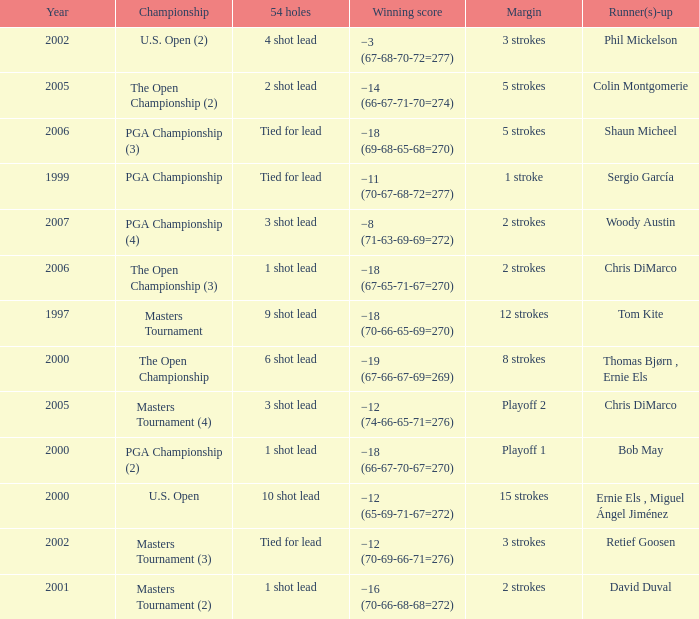What is the minimum year where winning score is −8 (71-63-69-69=272) 2007.0. 